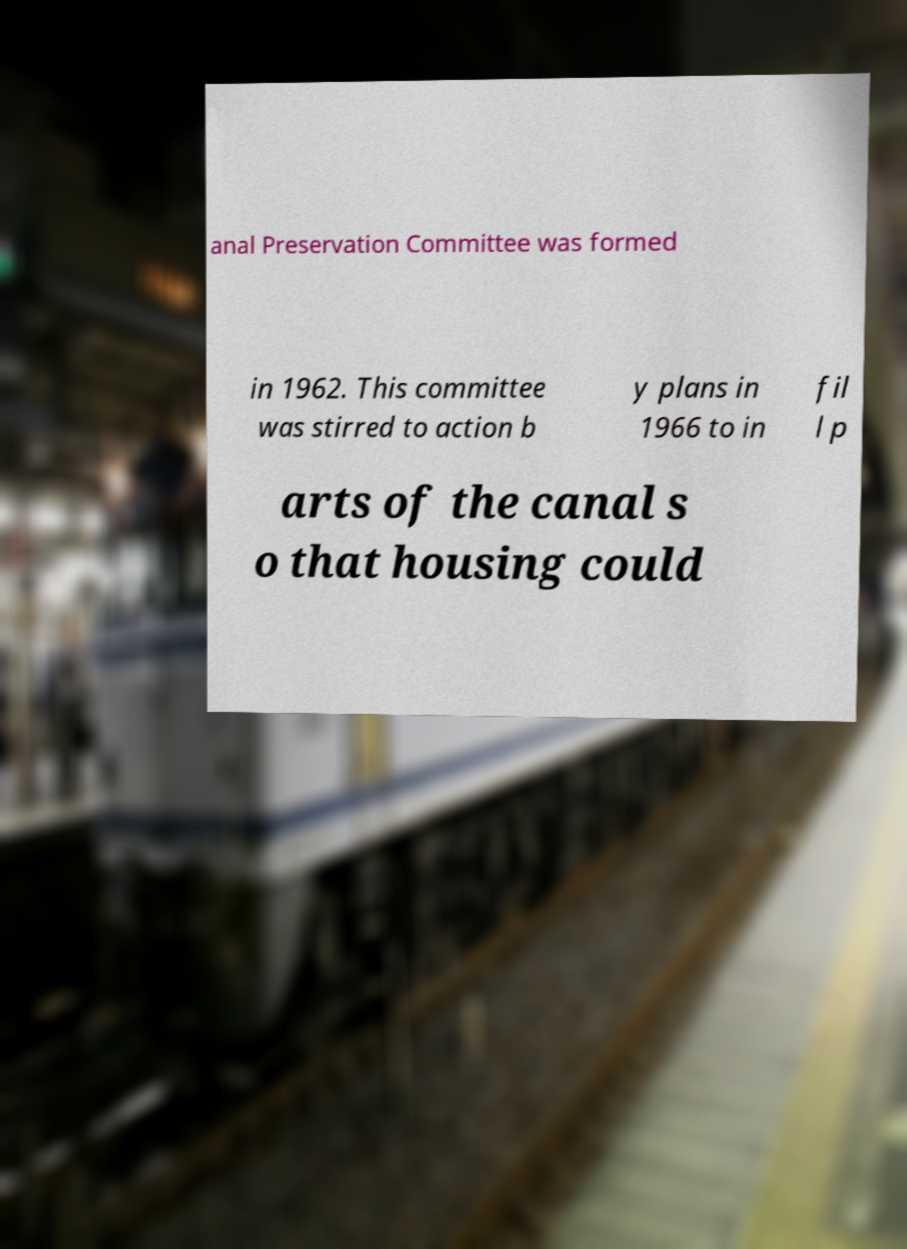What messages or text are displayed in this image? I need them in a readable, typed format. anal Preservation Committee was formed in 1962. This committee was stirred to action b y plans in 1966 to in fil l p arts of the canal s o that housing could 